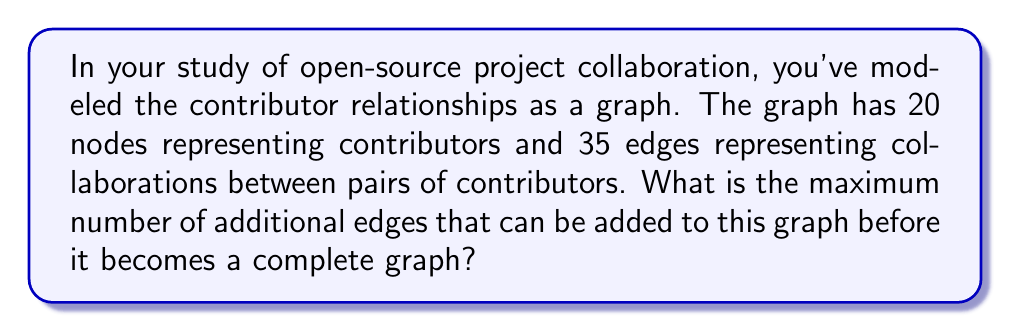Can you solve this math problem? To solve this problem, we need to follow these steps:

1) First, recall that a complete graph is a graph where every pair of distinct vertices is connected by a unique edge.

2) For a graph with $n$ vertices, the total number of edges in a complete graph is given by the formula:

   $$E_{complete} = \frac{n(n-1)}{2}$$

3) In this case, we have 20 nodes (contributors), so the number of edges in a complete graph with 20 nodes would be:

   $$E_{complete} = \frac{20(20-1)}{2} = \frac{20 \times 19}{2} = 190$$

4) The current graph has 35 edges. To find the maximum number of additional edges, we need to subtract the current number of edges from the total number of edges in a complete graph:

   $$E_{additional} = E_{complete} - E_{current} = 190 - 35 = 155$$

Therefore, a maximum of 155 additional edges can be added before the graph becomes complete.

This result represents the maximum number of new collaborations that could potentially form among the contributors before every contributor has collaborated with every other contributor at least once.
Answer: 155 